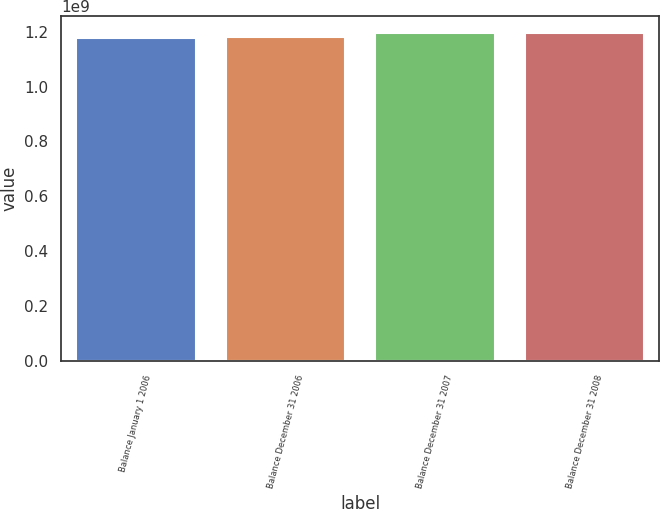Convert chart. <chart><loc_0><loc_0><loc_500><loc_500><bar_chart><fcel>Balance January 1 2006<fcel>Balance December 31 2006<fcel>Balance December 31 2007<fcel>Balance December 31 2008<nl><fcel>1.1776e+09<fcel>1.17941e+09<fcel>1.1959e+09<fcel>1.1941e+09<nl></chart> 